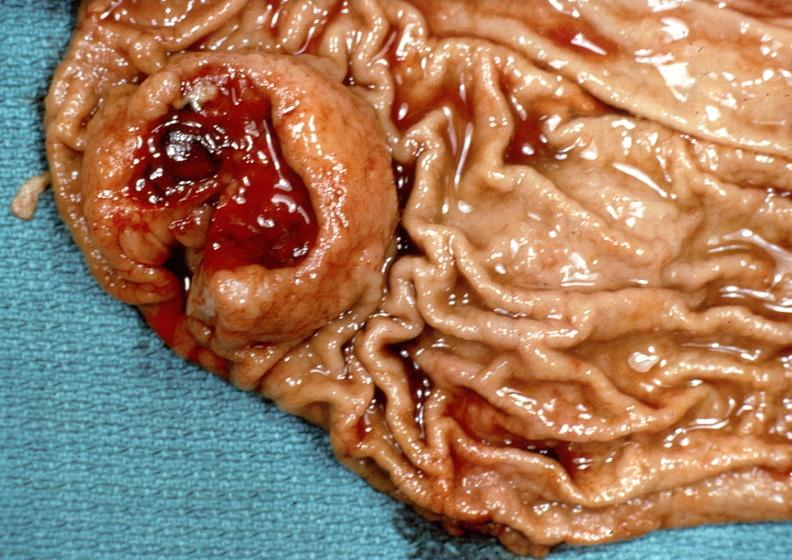s rheumatoid arthritis present?
Answer the question using a single word or phrase. No 